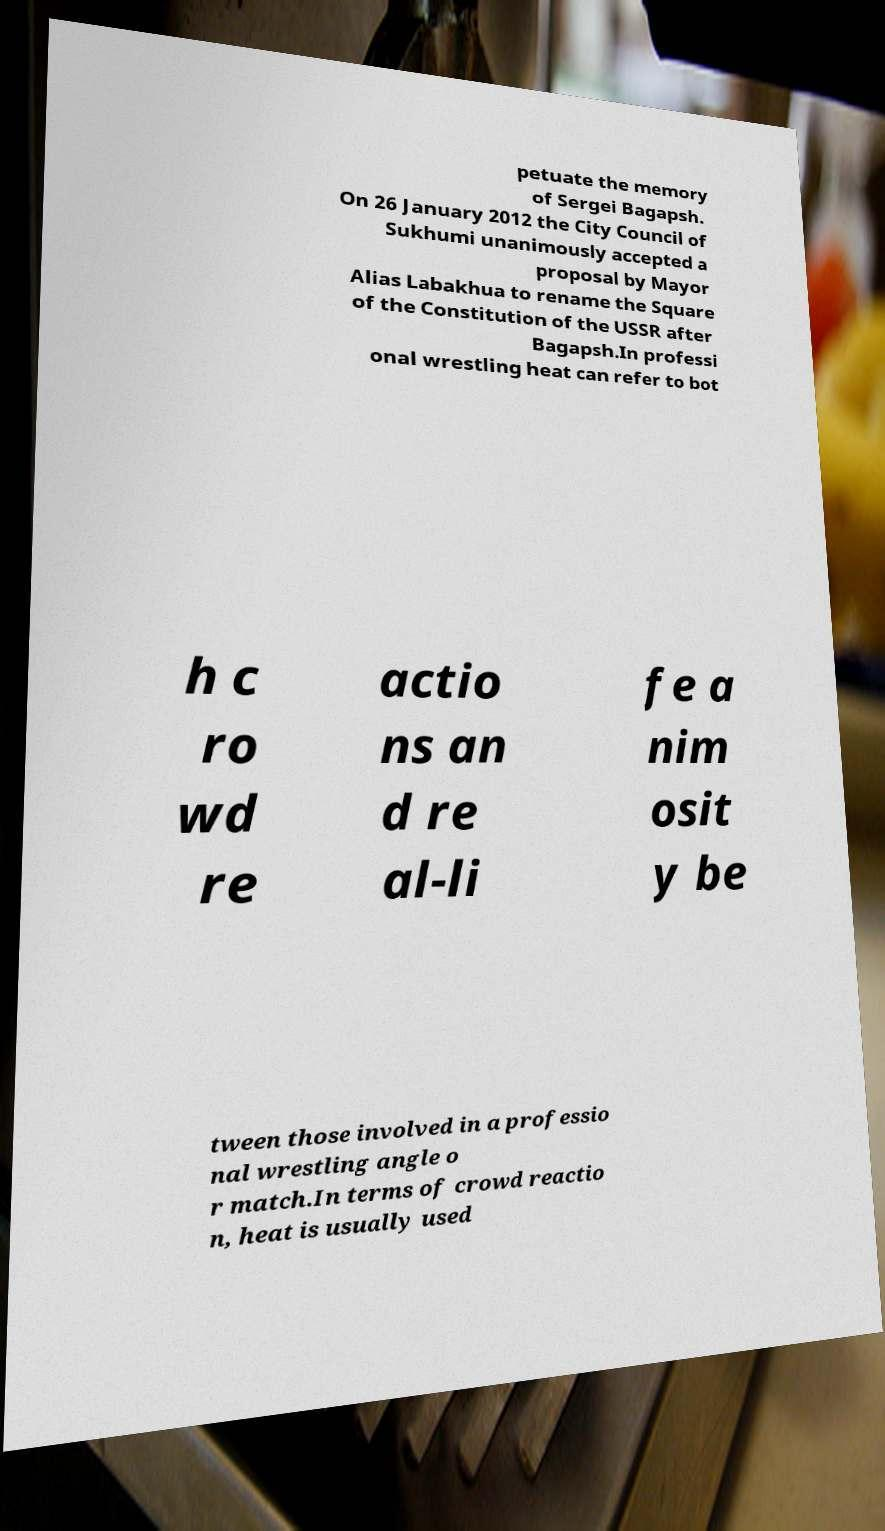Please read and relay the text visible in this image. What does it say? petuate the memory of Sergei Bagapsh. On 26 January 2012 the City Council of Sukhumi unanimously accepted a proposal by Mayor Alias Labakhua to rename the Square of the Constitution of the USSR after Bagapsh.In professi onal wrestling heat can refer to bot h c ro wd re actio ns an d re al-li fe a nim osit y be tween those involved in a professio nal wrestling angle o r match.In terms of crowd reactio n, heat is usually used 